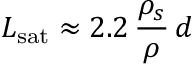<formula> <loc_0><loc_0><loc_500><loc_500>L _ { s a t } \approx 2 . 2 \, \frac { \rho _ { s } } { \rho } \, d</formula> 